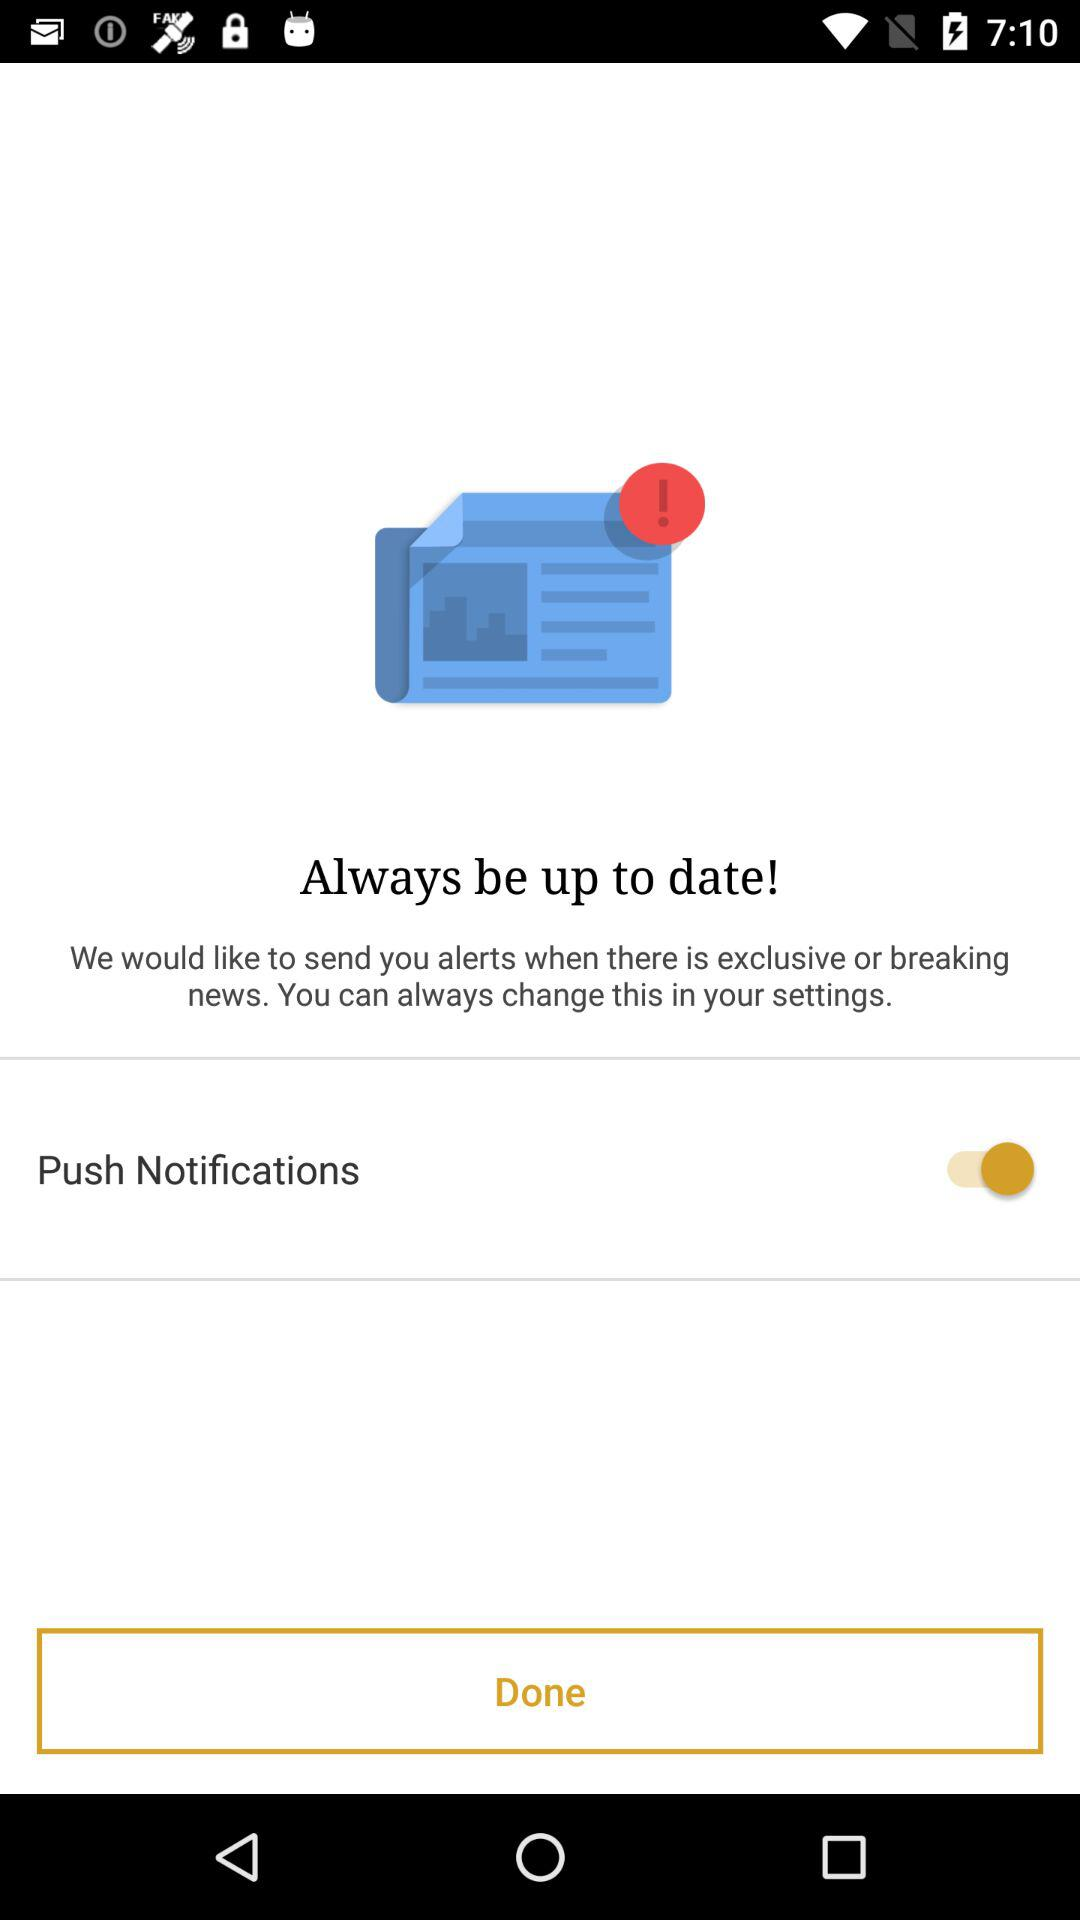What is the status of "Push Notification"? The status is "on". 